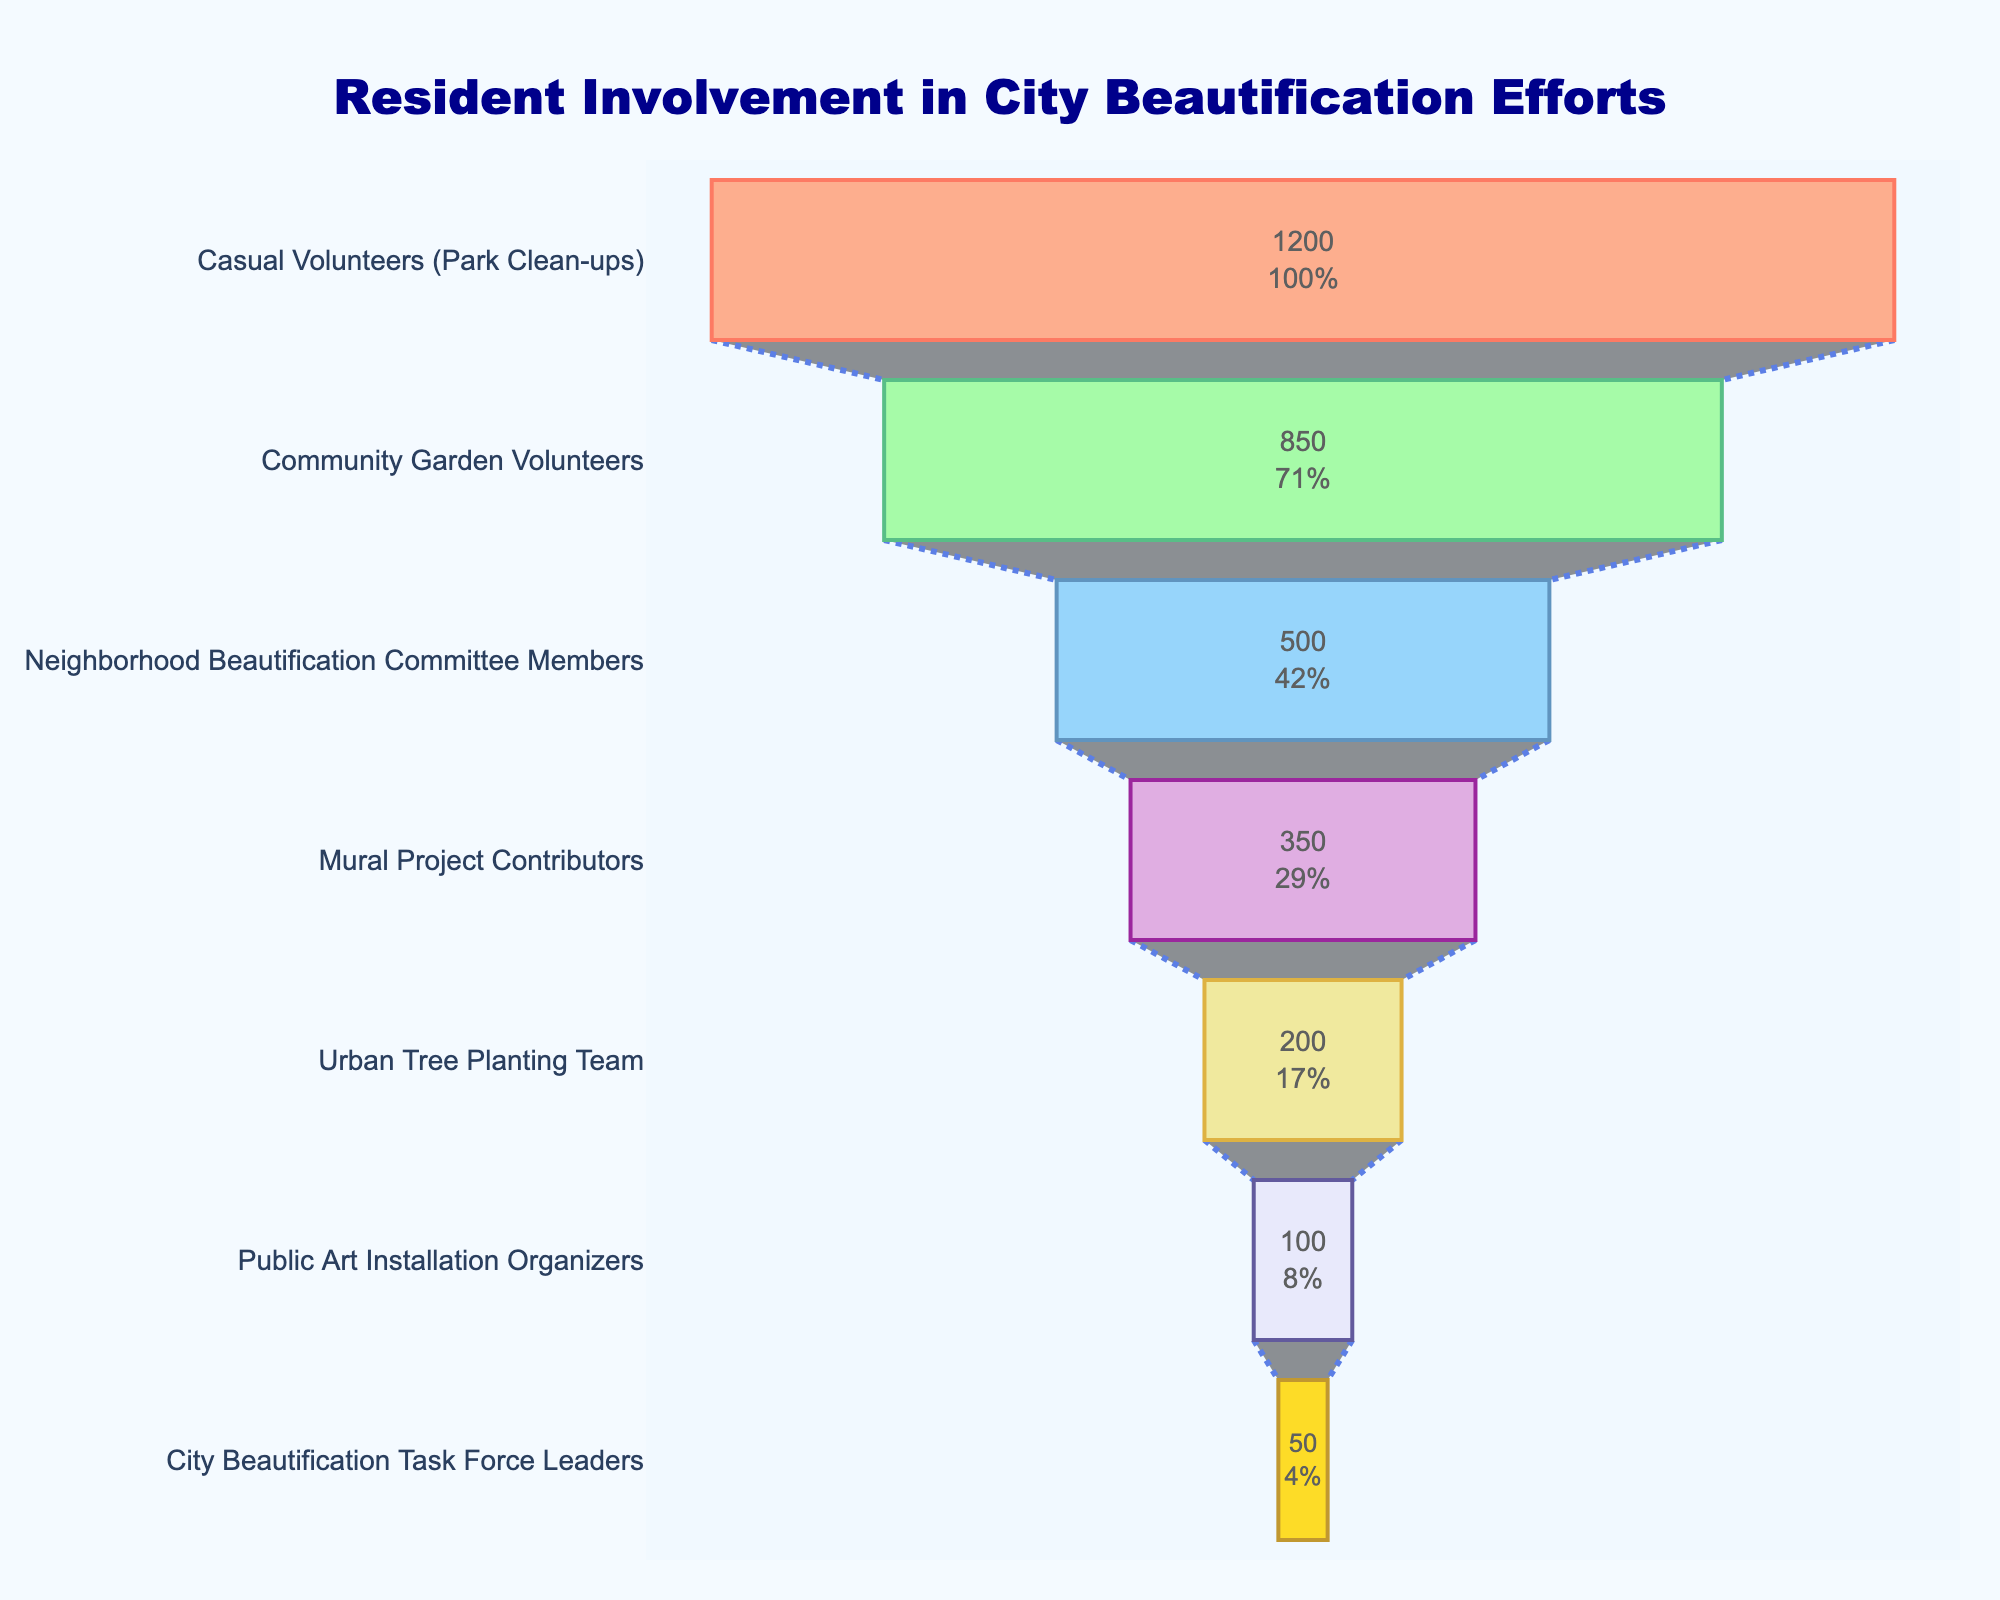What is the total number of casual volunteers involved in park clean-ups? Look at the first stage of the funnel chart labeled "Casual Volunteers (Park Clean-ups)" and refer to the number displayed inside the bar.
Answer: 1200 Which stage has the fewest participants? Compare all the stages and identify the one with the lowest number of participants from the funnel chart.
Answer: City Beautification Task Force Leaders Among the stages listed, which one has the highest percentage drop compared to its preceding stage? Calculate the percentage drop for each stage by comparing its number of participants to the preceding stage. Identify the stage with the highest percentage drop.
Answer: City Beautification Task Force Leaders What percentage of the initial number of casual volunteers does each stage represent? Calculate the percentage of the initial number of casual volunteers (1200) that each stage represents by dividing the number of participants in each stage by 1200 and multiplying by 100%.
Answer: Community Garden Volunteers: 70.83%, Neighborhood Beautification Committee Members: 41.67%, Mural Project Contributors: 29.17%, Urban Tree Planting Team: 16.67%, Public Art Installation Organizers: 8.33%, City Beautification Task Force Leaders: 4.17% 